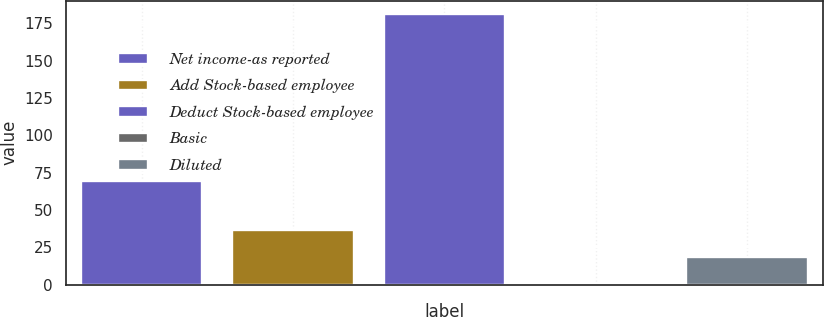Convert chart. <chart><loc_0><loc_0><loc_500><loc_500><bar_chart><fcel>Net income-as reported<fcel>Add Stock-based employee<fcel>Deduct Stock-based employee<fcel>Basic<fcel>Diluted<nl><fcel>69<fcel>36.35<fcel>181<fcel>0.19<fcel>18.27<nl></chart> 